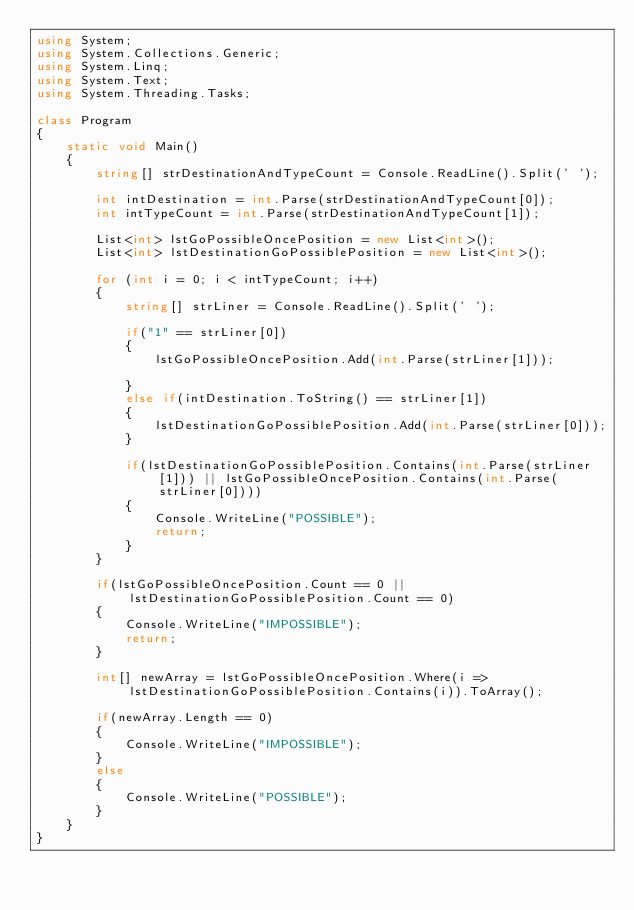<code> <loc_0><loc_0><loc_500><loc_500><_C#_>using System;
using System.Collections.Generic;
using System.Linq;
using System.Text;
using System.Threading.Tasks;

class Program
{
    static void Main()
    {
        string[] strDestinationAndTypeCount = Console.ReadLine().Split(' ');

        int intDestination = int.Parse(strDestinationAndTypeCount[0]);
        int intTypeCount = int.Parse(strDestinationAndTypeCount[1]);

        List<int> lstGoPossibleOncePosition = new List<int>();
        List<int> lstDestinationGoPossiblePosition = new List<int>();

        for (int i = 0; i < intTypeCount; i++)
        {
            string[] strLiner = Console.ReadLine().Split(' ');

            if("1" == strLiner[0])
            {
                lstGoPossibleOncePosition.Add(int.Parse(strLiner[1]));
                
            }
            else if(intDestination.ToString() == strLiner[1])
            {
                lstDestinationGoPossiblePosition.Add(int.Parse(strLiner[0]));
            }

            if(lstDestinationGoPossiblePosition.Contains(int.Parse(strLiner[1])) || lstGoPossibleOncePosition.Contains(int.Parse(strLiner[0])))
            {
                Console.WriteLine("POSSIBLE");
                return;
            }
        }

        if(lstGoPossibleOncePosition.Count == 0 || lstDestinationGoPossiblePosition.Count == 0)
        {
            Console.WriteLine("IMPOSSIBLE");
            return;
        }

        int[] newArray = lstGoPossibleOncePosition.Where(i => lstDestinationGoPossiblePosition.Contains(i)).ToArray();

        if(newArray.Length == 0)
        {
            Console.WriteLine("IMPOSSIBLE");
        }
        else
        {
            Console.WriteLine("POSSIBLE");
        }
    }
}</code> 